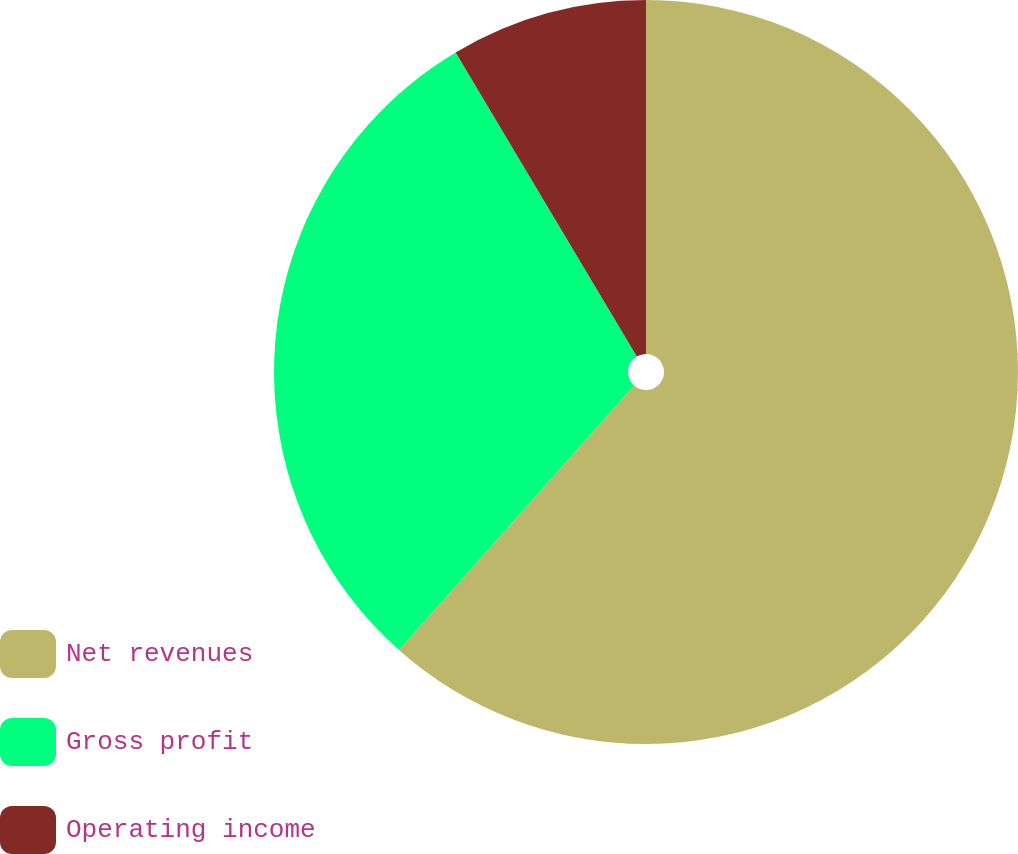Convert chart to OTSL. <chart><loc_0><loc_0><loc_500><loc_500><pie_chart><fcel>Net revenues<fcel>Gross profit<fcel>Operating income<nl><fcel>61.56%<fcel>29.89%<fcel>8.55%<nl></chart> 